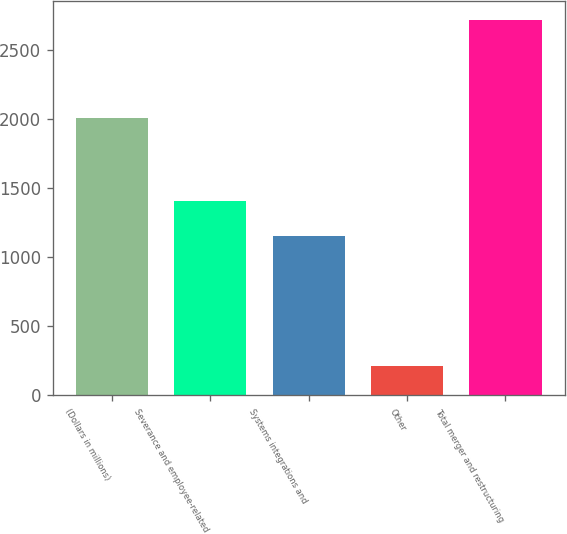Convert chart to OTSL. <chart><loc_0><loc_0><loc_500><loc_500><bar_chart><fcel>(Dollars in millions)<fcel>Severance and employee-related<fcel>Systems integrations and<fcel>Other<fcel>Total merger and restructuring<nl><fcel>2009<fcel>1405.6<fcel>1155<fcel>215<fcel>2721<nl></chart> 